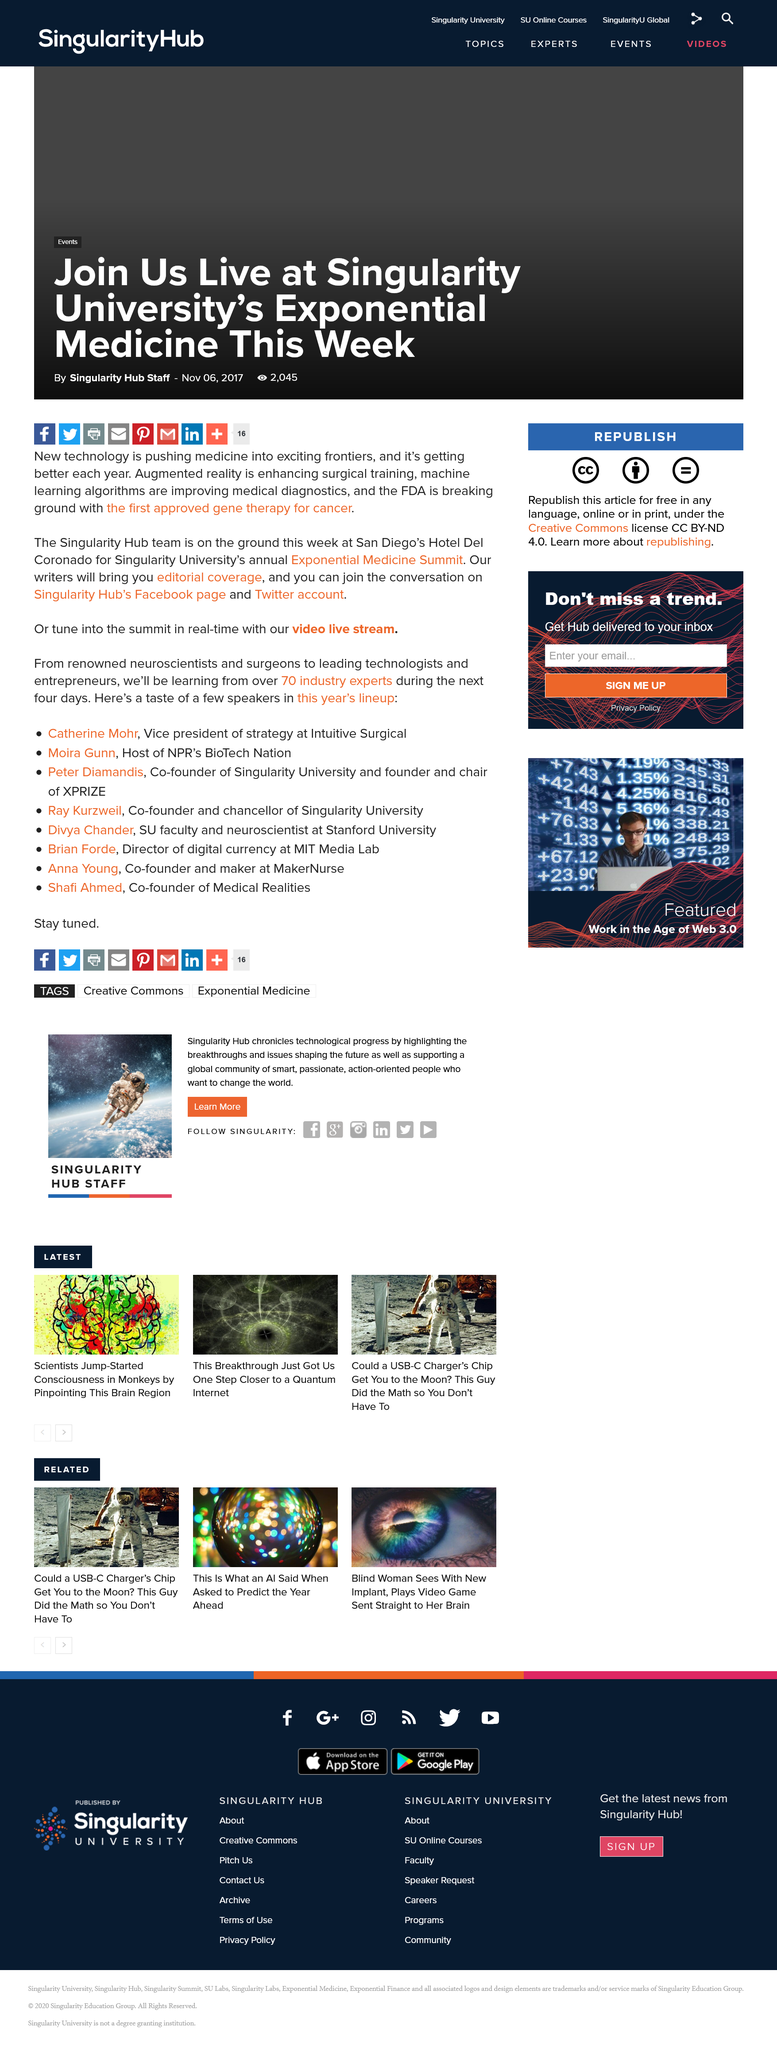Draw attention to some important aspects in this diagram. The Exponential Medicine Summit is being hosted at the Hotel Del Coronado. Augmented reality is enhancing surgical training, as stated in the article. Exponential Medicine, organized by Singularity University, is taking place this week in the month of November in the year 2017. 